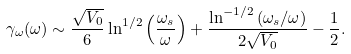<formula> <loc_0><loc_0><loc_500><loc_500>\gamma _ { \omega } ( \omega ) \sim \frac { \sqrt { V _ { 0 } } } { 6 } \ln ^ { 1 / 2 } \left ( \frac { \omega _ { s } } { \omega } \right ) + \frac { \ln ^ { - 1 / 2 } \left ( \omega _ { s } / \omega \right ) } { 2 \sqrt { V _ { 0 } } } - \frac { 1 } { 2 } .</formula> 